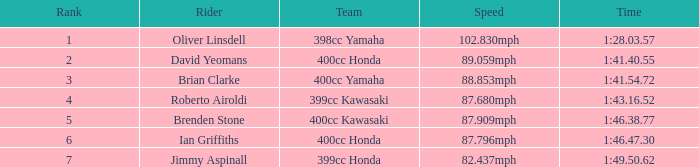What is the time of the rider with a 398cc yamaha? 1:28.03.57. 